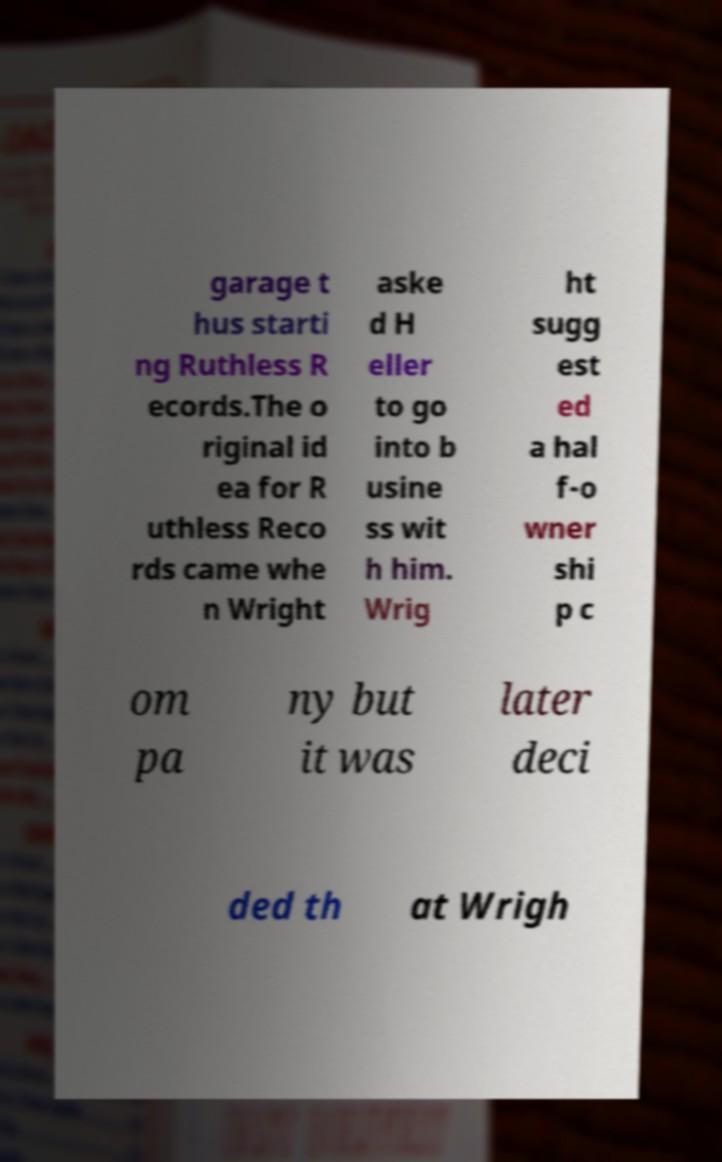Can you accurately transcribe the text from the provided image for me? garage t hus starti ng Ruthless R ecords.The o riginal id ea for R uthless Reco rds came whe n Wright aske d H eller to go into b usine ss wit h him. Wrig ht sugg est ed a hal f-o wner shi p c om pa ny but it was later deci ded th at Wrigh 